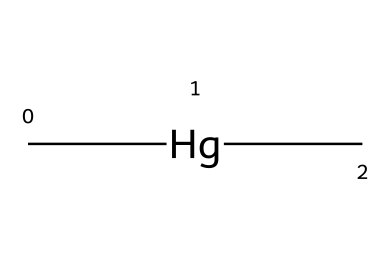What is the total number of atoms in dimethylmercury? The chemical structure shows two carbon (C) atoms and one mercury (Hg) atom, summing up to a total of three atoms.
Answer: three How many carbon atoms are present in dimethylmercury? Looking at the structure, there are two carbon (C) atoms connected to the mercury (Hg) atom.
Answer: two What type of bonding is present between the mercury and carbon atoms? The structure indicates single covalent bonds connecting the mercury (Hg) atom to each of the two carbon (C) atoms.
Answer: single covalent What is the primary environmental concern associated with dimethylmercury? Dimethylmercury is well-known for its high toxicity and bioaccumulation, particularly in aquatic environments, posing a risk to ecosystems and human health.
Answer: toxicity Why is dimethylmercury classified as an organometallic compound? It contains a metal atom (mercury) bonded to carbon atoms, which is a defining characteristic of organometallic compounds.
Answer: organometallic How many hydrogen atoms are attached to the carbon atoms in dimethylmercury? Each carbon atom in dimethylmercury is attached to three hydrogen (H) atoms, making a total of six hydrogen atoms.
Answer: six What is the significance of methyl groups in the structure of dimethylmercury? The presence of two methyl (CH3) groups is critical as they influence the compound's properties, including its volatility and reactivity as a toxic substance.
Answer: volatility 